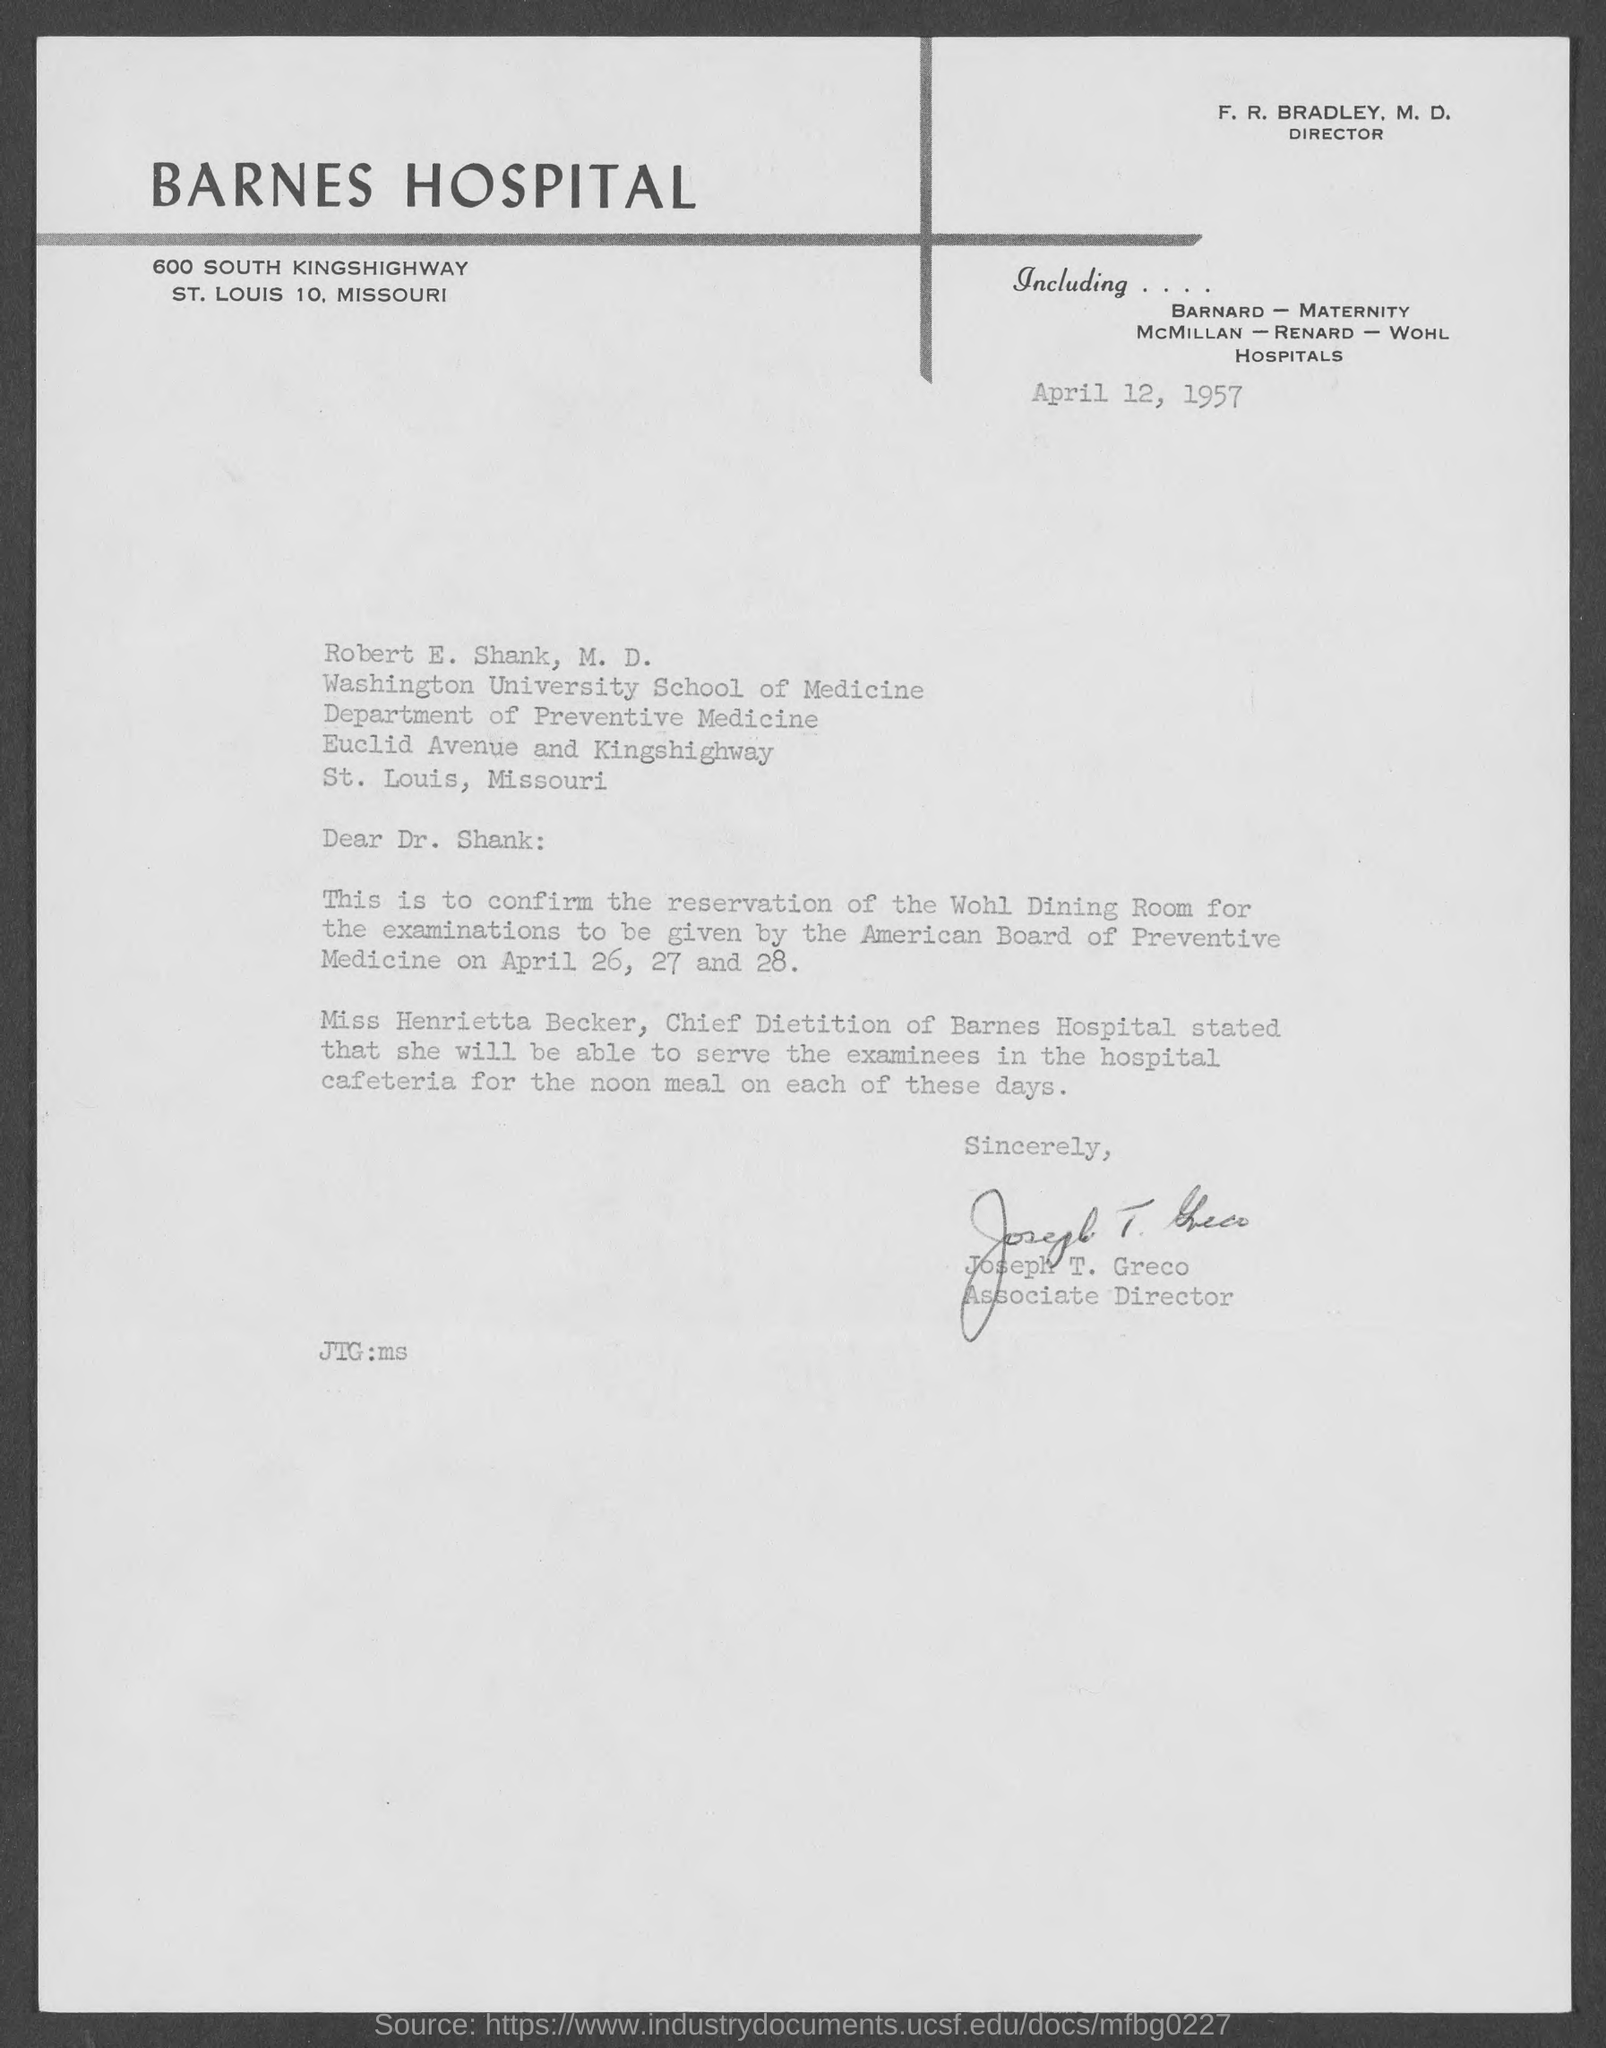What is the date mentioned in the top of the document ?
Your answer should be compact. April 12, 1957. Who is the Associate Director ?
Provide a short and direct response. Joseph T. Greco. What is written in the "JTG" field ?
Your answer should be very brief. JTG:ms. 